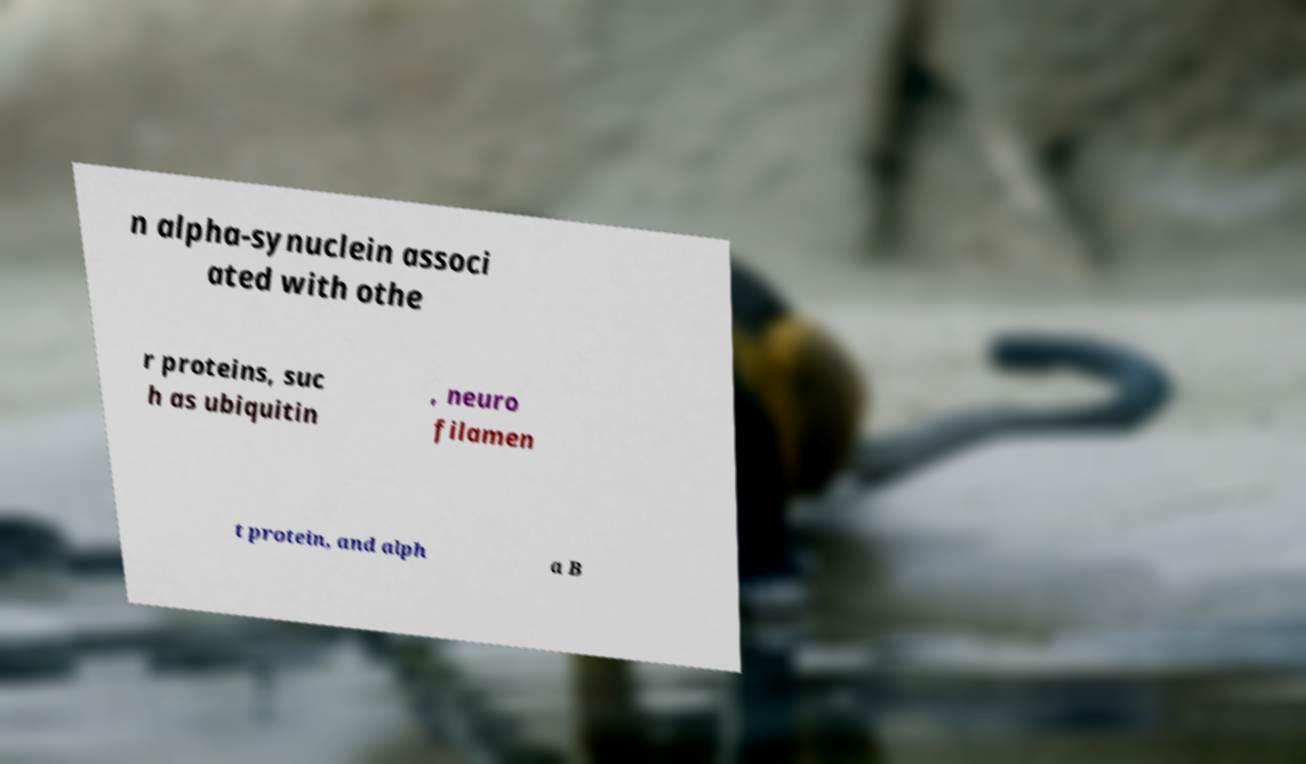Could you assist in decoding the text presented in this image and type it out clearly? n alpha-synuclein associ ated with othe r proteins, suc h as ubiquitin , neuro filamen t protein, and alph a B 